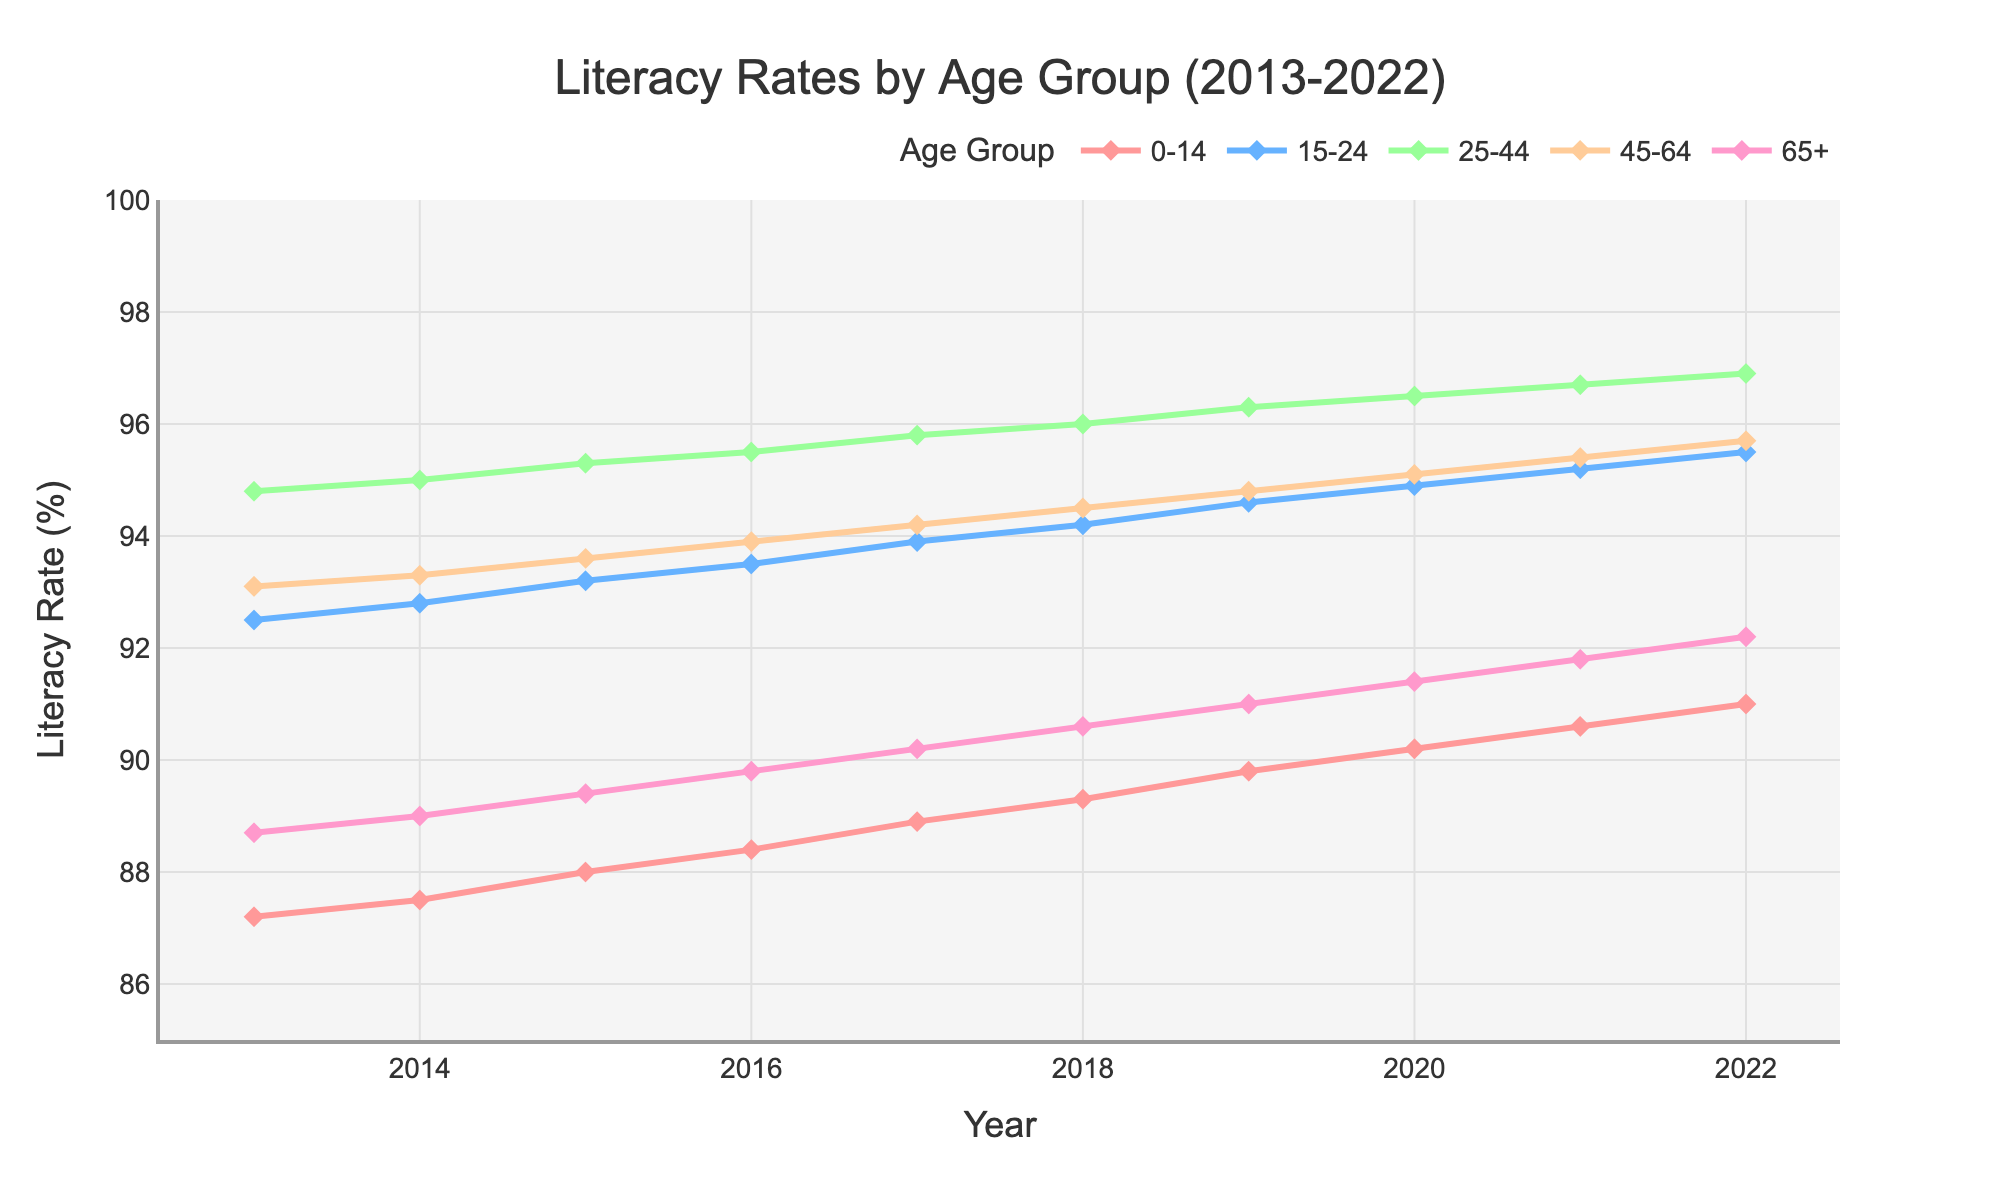How did the literacy rate for the age group 0-14 change from 2013 to 2022? The literacy rate for the age group 0-14 increased steadily over the years from 87.2% in 2013 to 91.0% in 2022.
Answer: It increased Which age group had the highest literacy rate in 2022? The age group 25-44 had the highest literacy rate in 2022 with a rate of 96.9%.
Answer: 25-44 Which age group shows the smallest increase in literacy rate from 2013 to 2022? The age group 65+ had an increase from 88.7% in 2013 to 92.2% in 2022. Compare this increase of 3.5% with other groups to find it's the smallest.
Answer: 65+ By how much did the literacy rate for the age group 45-64 increase between 2013 and 2022? The literacy rate for the age group 45-64 was 93.1% in 2013 and 95.7% in 2022. The increase is 95.7% - 93.1% = 2.6%.
Answer: 2.6% In which year did the age group 15-24 surpass a literacy rate of 95%? The age group 15-24 surpassed a literacy rate of 95% in 2021 with a rate of 95.2%.
Answer: 2021 What is the average literacy rate of the age group 25-44 over the decade? To find the average literacy rate of the age group 25-44 over the decade, sum the rates from 2013 to 2022 and divide by the number of years. The sum is 94.8 + 95.0 + 95.3 + 95.5 + 95.8 + 96.0 + 96.3 + 96.5 + 96.7 + 96.9 = 958.8. The average is 958.8 / 10 = 95.88%.
Answer: 95.88% Which age group had the most significant improvement in literacy rate over the decade? The age group with the most significant improvement is the 0-14 group, increasing from 87.2% in 2013 to 91.0% in 2022 which is an improvement of 3.8%. Compare improvements across groups: 3.8% (0-14), 3.0% (15-24), 2.1% (25-44), 2.6% (45-64), and 3.5% (65+).
Answer: 0-14 Do the literacy rates of any age groups show a decline at any point over the decade? All age groups show a consistent increase in literacy rates from 2013 to 2022, with no declines at any point over the decade.
Answer: No 